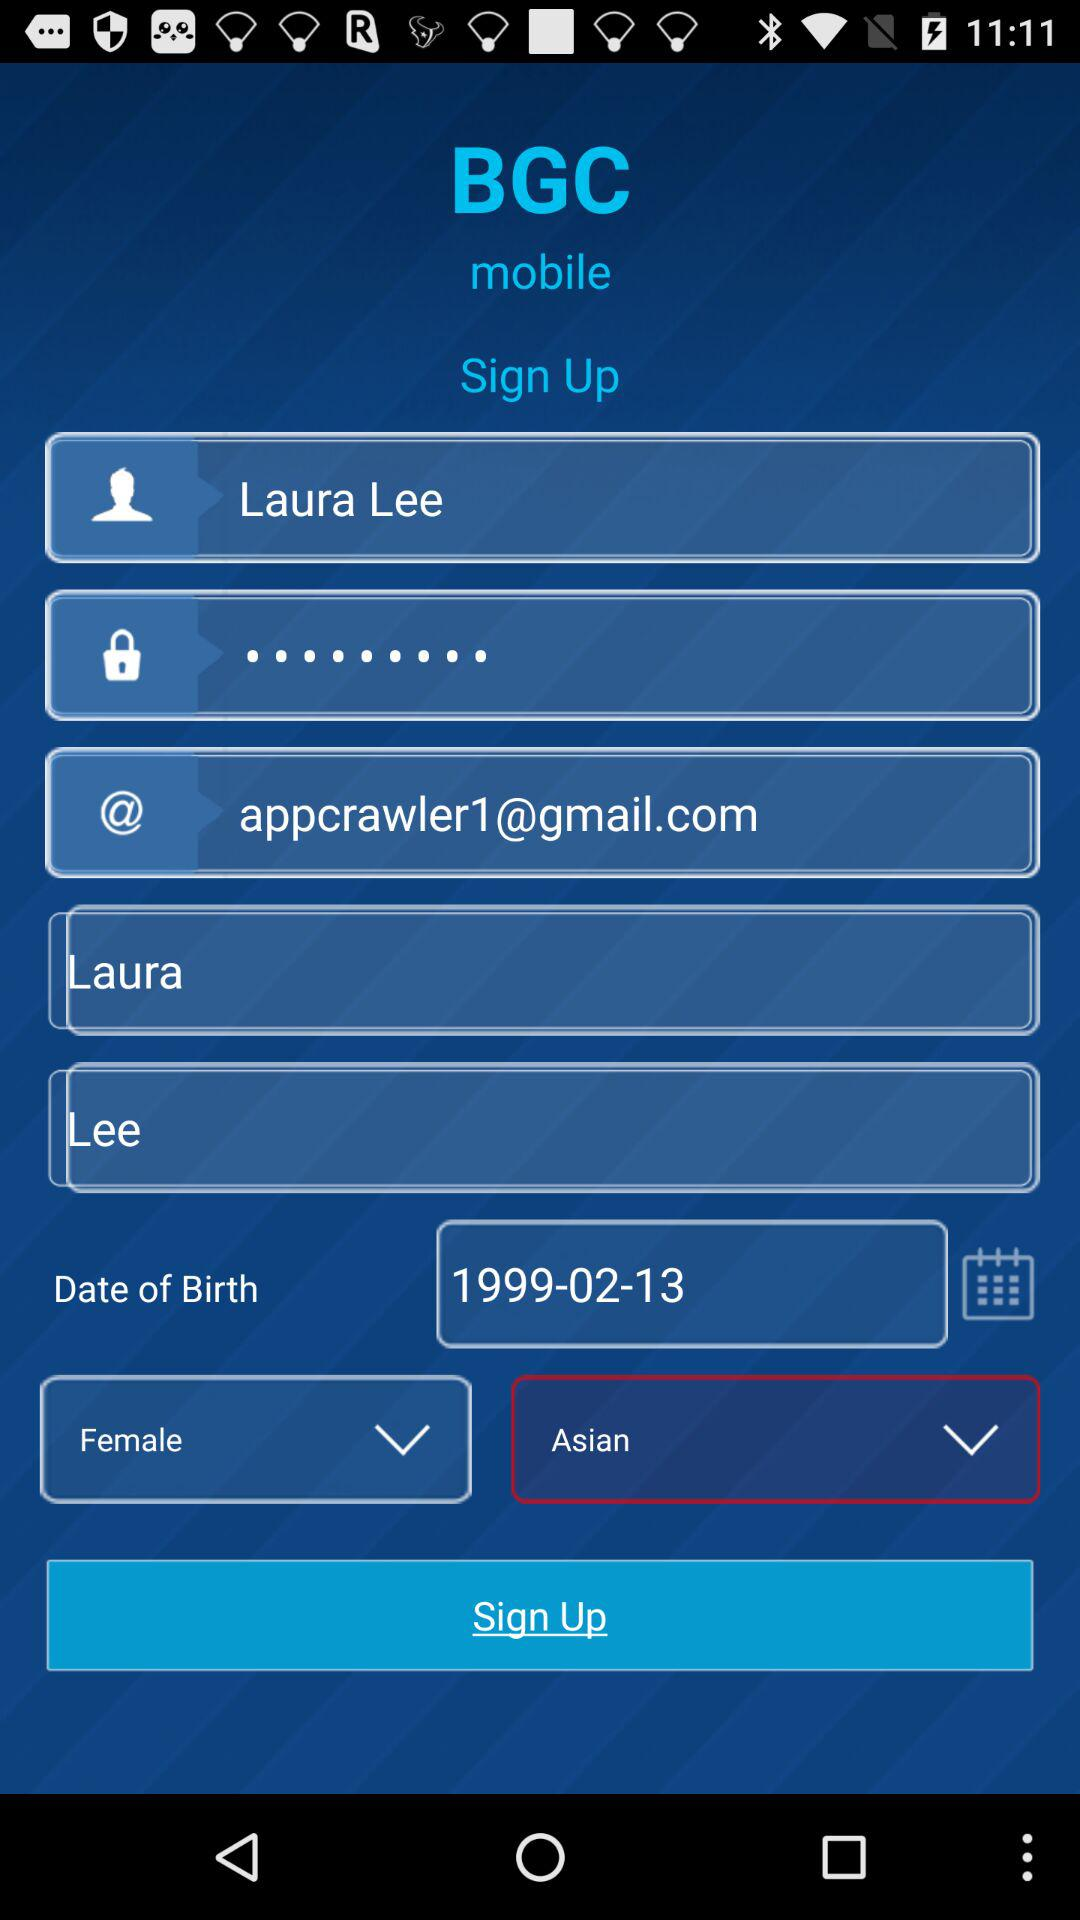What is the date of birth? The date of birth is 1999-02-13. 